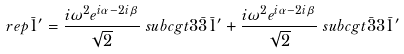<formula> <loc_0><loc_0><loc_500><loc_500>\ r e p { \bar { 1 } ^ { \prime } } & = \frac { i \omega ^ { 2 } e ^ { i \alpha - 2 i \beta } } { \sqrt { 2 } } \ s u b c g t { 3 } { \bar { 3 } } { \bar { 1 } ^ { \prime } } + \frac { i \omega ^ { 2 } e ^ { i \alpha - 2 i \beta } } { \sqrt { 2 } } \ s u b c g t { \bar { 3 } } { 3 } { \bar { 1 } ^ { \prime } }</formula> 